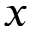<formula> <loc_0><loc_0><loc_500><loc_500>x</formula> 